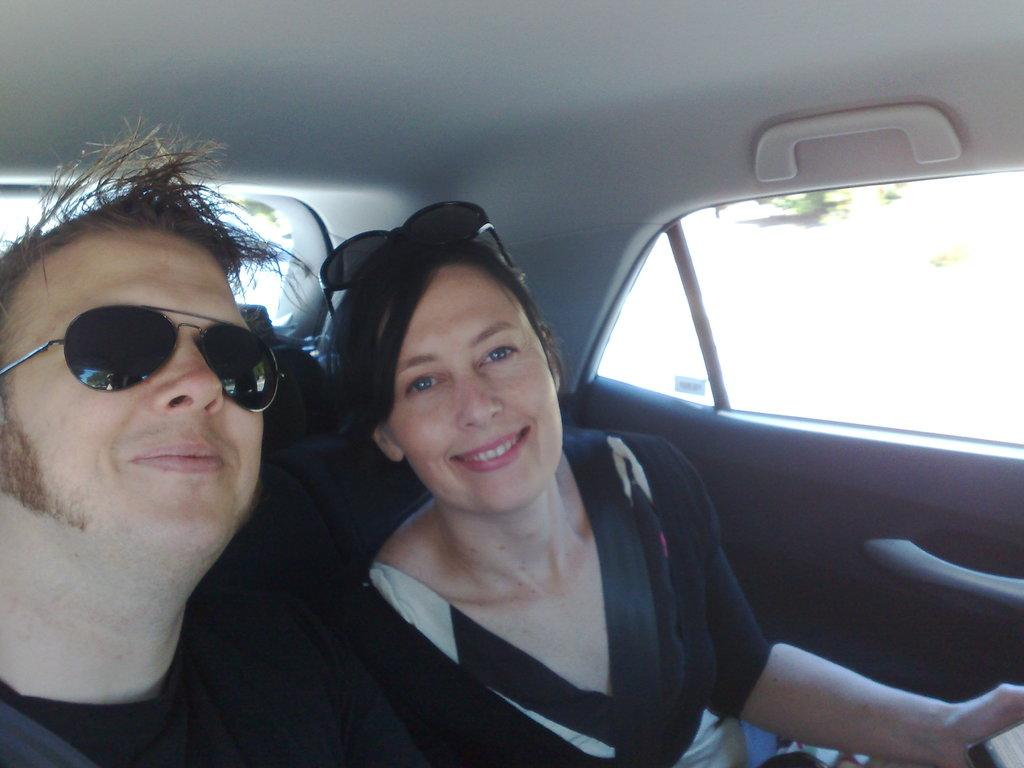Who is present in the image? There is a man and a woman in the image. What are the man and woman doing in the image? The man and woman are riding in a car. What type of icicle can be seen hanging from the car's roof in the image? There is no icicle present in the image; it is a man and a woman riding in a car. 